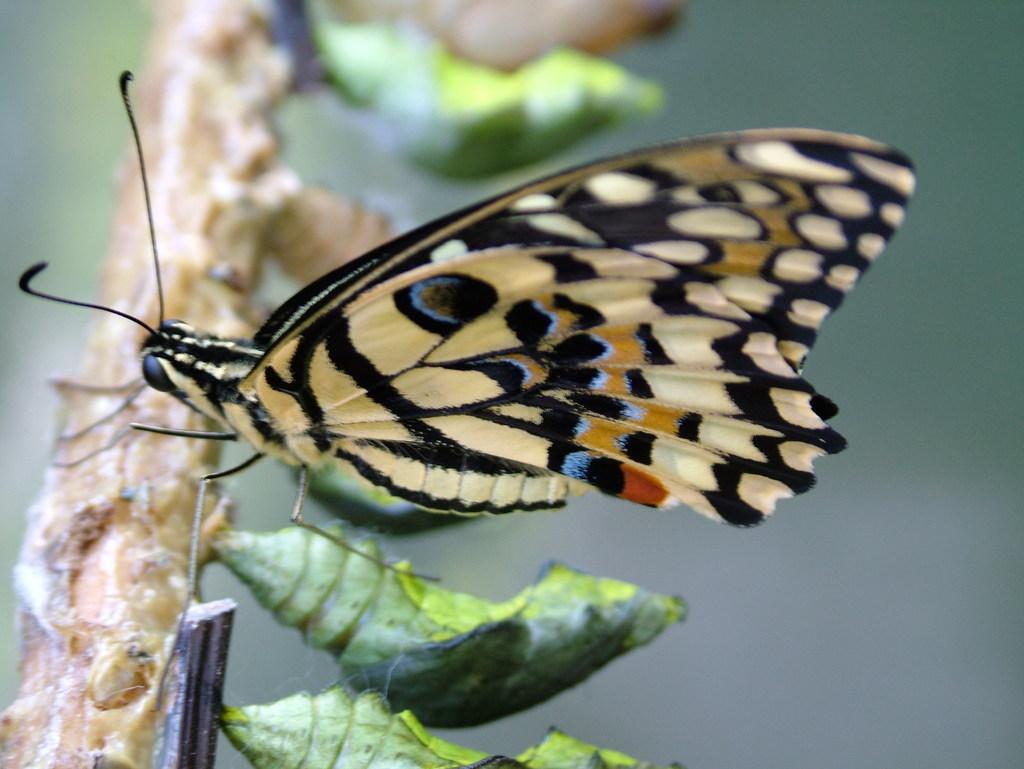Describe this image in one or two sentences. In this image we can see a butterfly and some cocoons on the branch of a tree. 